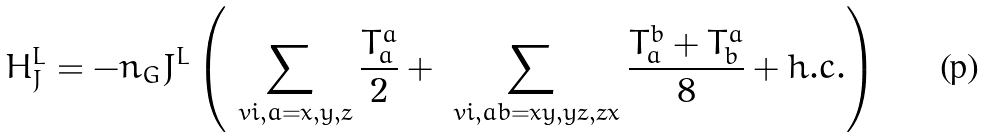Convert formula to latex. <formula><loc_0><loc_0><loc_500><loc_500>H _ { J } ^ { L } & = - n _ { G } J ^ { L } \left ( \sum _ { \ v i , a = x , y , z } \frac { T _ { a } ^ { a } } { 2 } + \sum _ { \ v i , a b = x y , y z , z x } \frac { T _ { a } ^ { b } + T _ { b } ^ { a } } { 8 } + h . c . \right )</formula> 